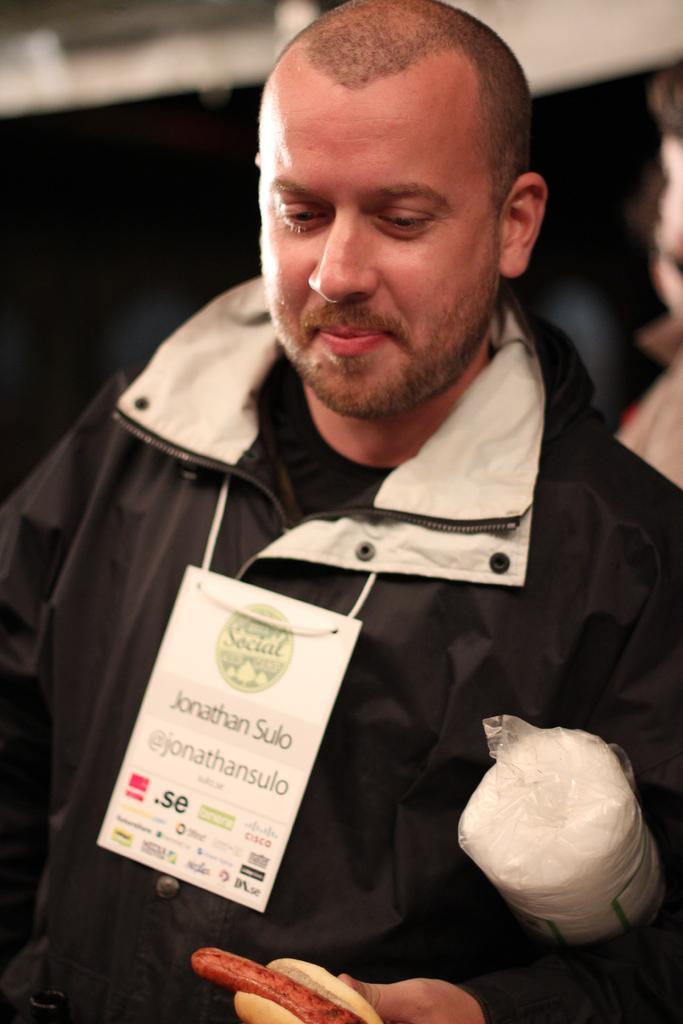Please provide a concise description of this image. In this image I can see a man is standing. The man is wearing black color jacket. The man is holding something in the hand. The background of the image is blurred. 